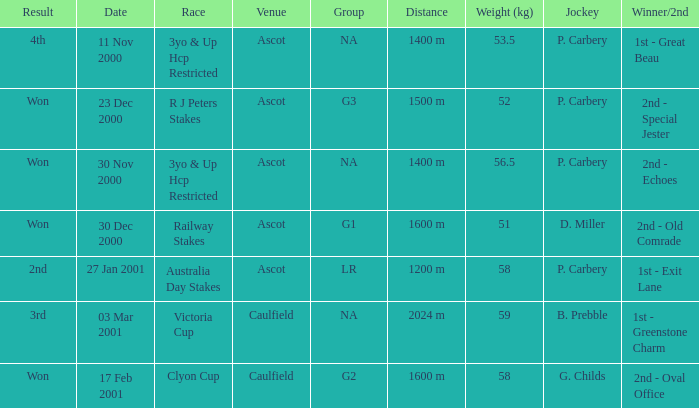What was the result for the railway stakes race? Won. 